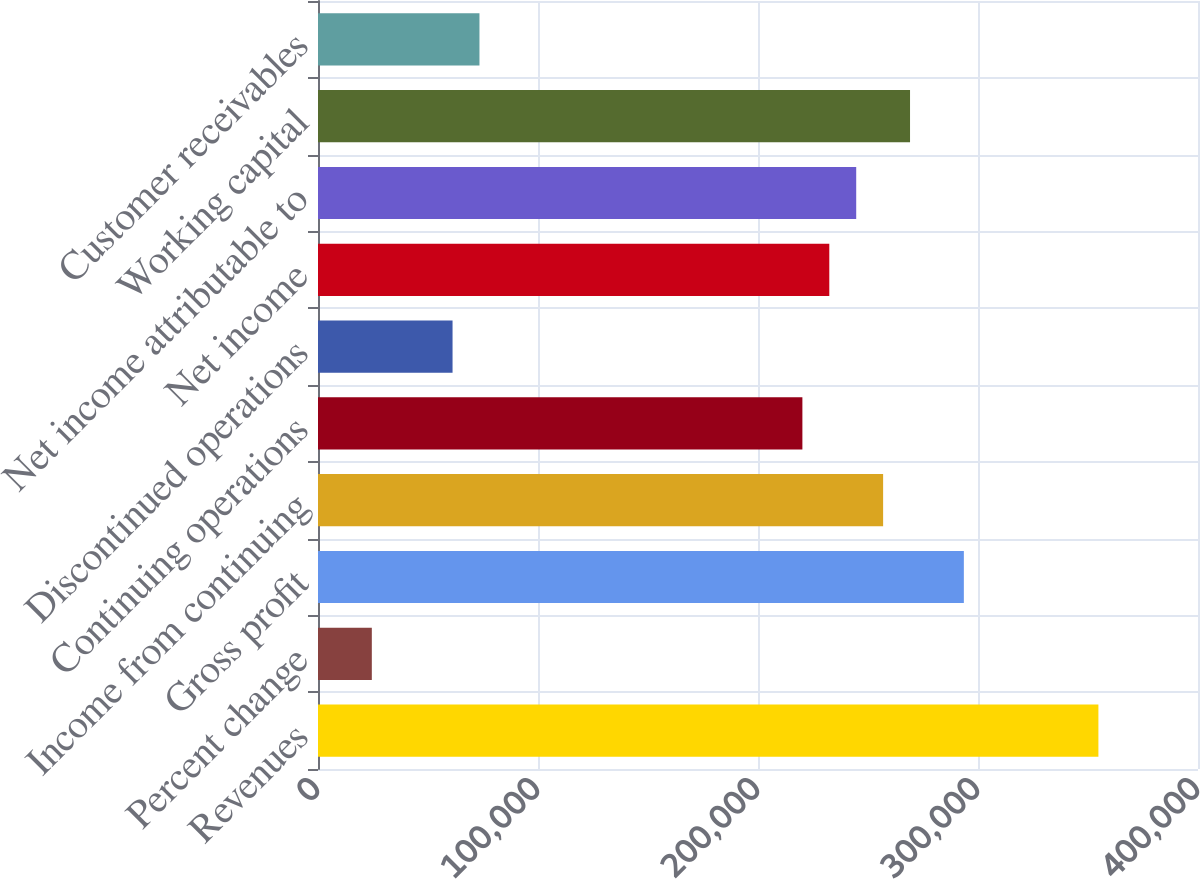Convert chart. <chart><loc_0><loc_0><loc_500><loc_500><bar_chart><fcel>Revenues<fcel>Percent change<fcel>Gross profit<fcel>Income from continuing<fcel>Continuing operations<fcel>Discontinued operations<fcel>Net income<fcel>Net income attributable to<fcel>Working capital<fcel>Customer receivables<nl><fcel>354729<fcel>24464.8<fcel>293569<fcel>256873<fcel>220177<fcel>61160.9<fcel>232409<fcel>244641<fcel>269105<fcel>73392.9<nl></chart> 